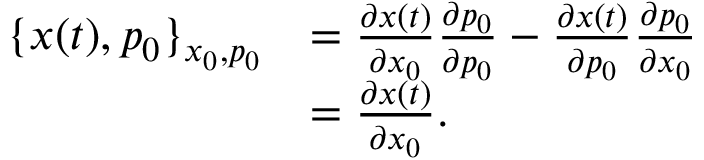Convert formula to latex. <formula><loc_0><loc_0><loc_500><loc_500>\begin{array} { r l } { \{ x ( t ) , p _ { 0 } \} _ { x _ { 0 } , p _ { 0 } } } & { = \frac { \partial x ( t ) } { \partial x _ { 0 } } \frac { \partial p _ { 0 } } { \partial p _ { 0 } } - \frac { \partial x ( t ) } { \partial p _ { 0 } } \frac { \partial p _ { 0 } } { \partial x _ { 0 } } } \\ & { = \frac { \partial x ( t ) } { \partial x _ { 0 } } . } \end{array}</formula> 